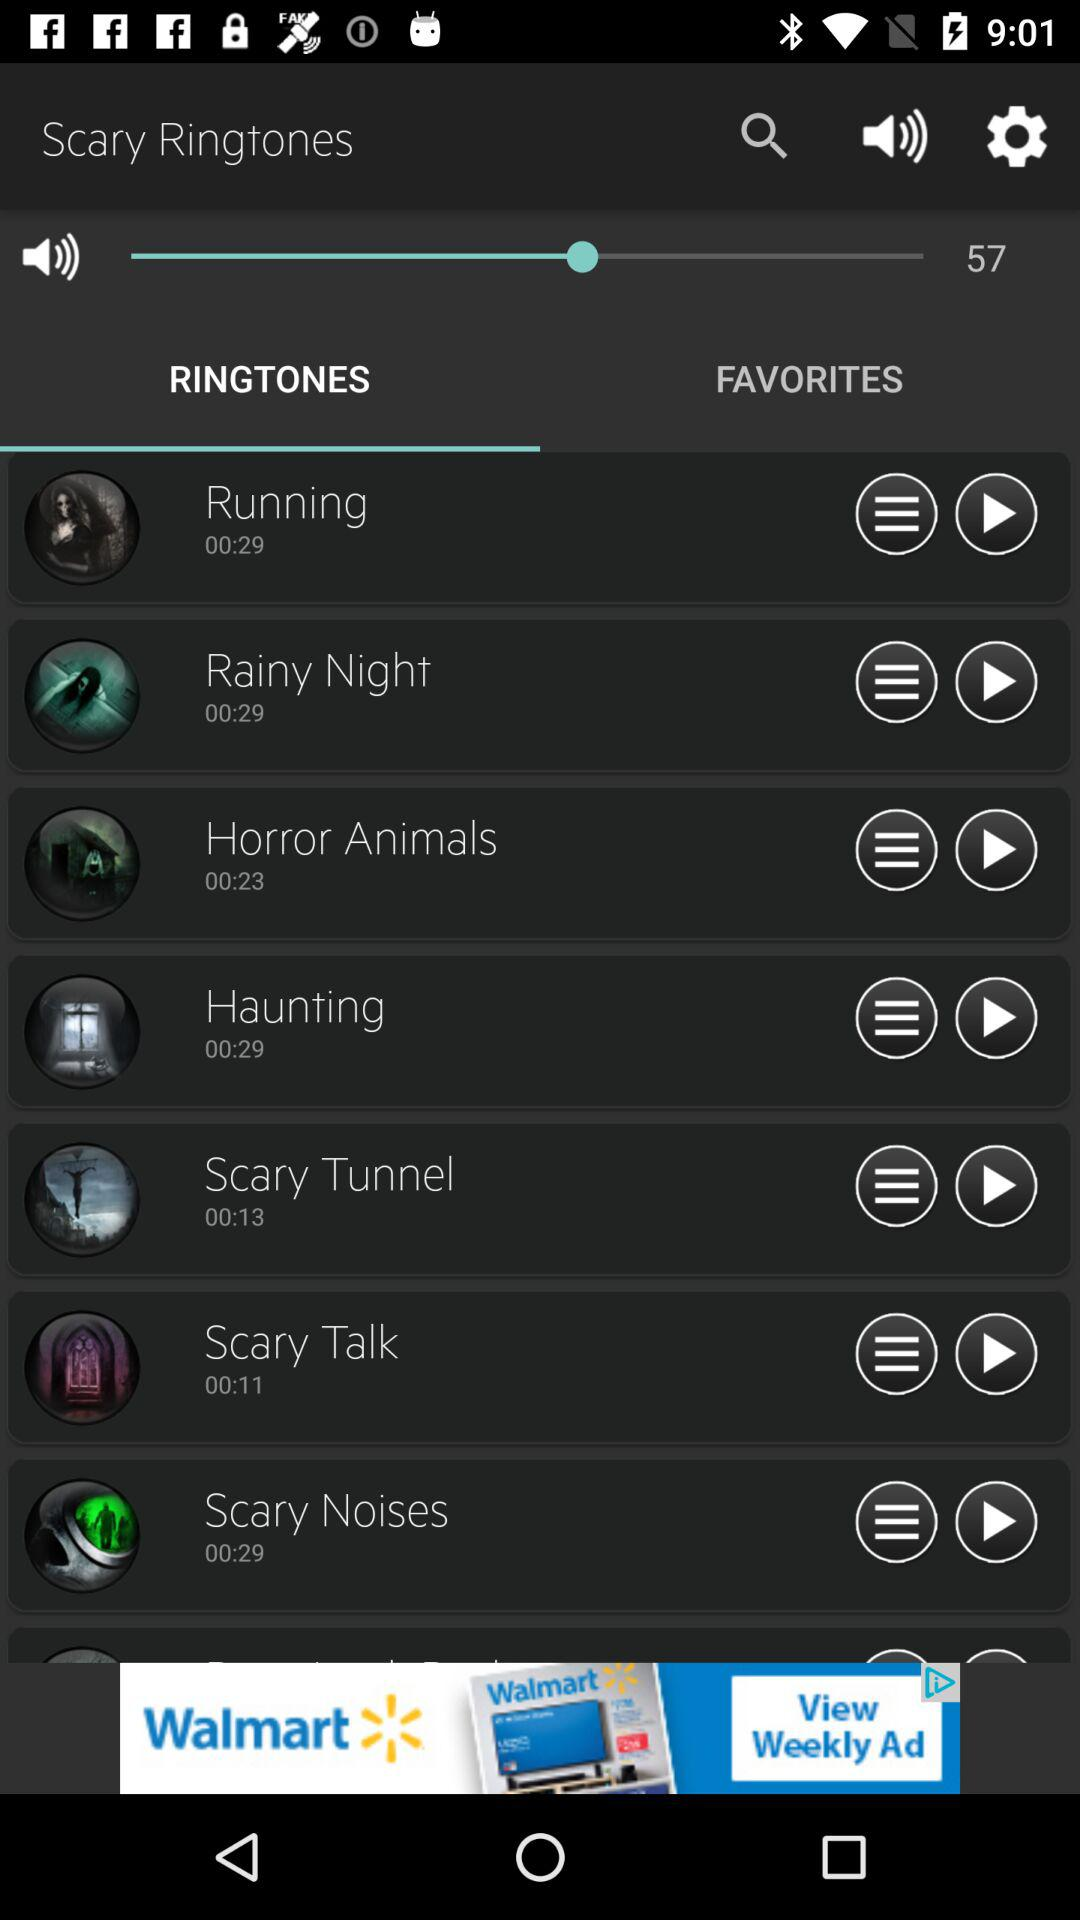Who is the artist of the "Running" ringtone?
When the provided information is insufficient, respond with <no answer>. <no answer> 